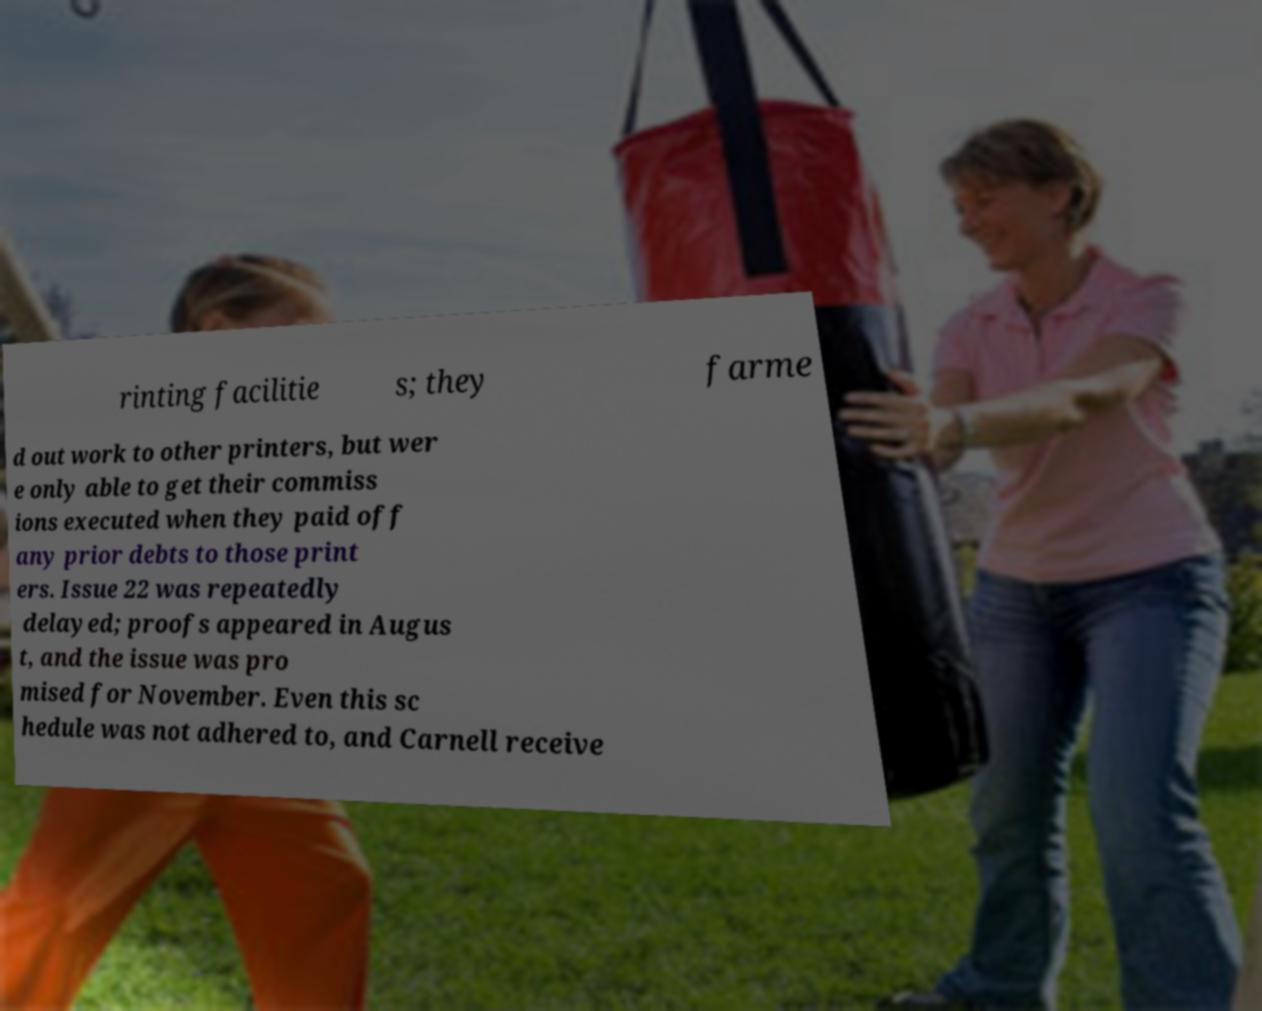Can you read and provide the text displayed in the image?This photo seems to have some interesting text. Can you extract and type it out for me? rinting facilitie s; they farme d out work to other printers, but wer e only able to get their commiss ions executed when they paid off any prior debts to those print ers. Issue 22 was repeatedly delayed; proofs appeared in Augus t, and the issue was pro mised for November. Even this sc hedule was not adhered to, and Carnell receive 